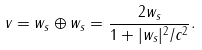Convert formula to latex. <formula><loc_0><loc_0><loc_500><loc_500>v = w _ { s } \oplus w _ { s } = \frac { 2 w _ { s } } { 1 + | w _ { s } | ^ { 2 } / c ^ { 2 } } .</formula> 